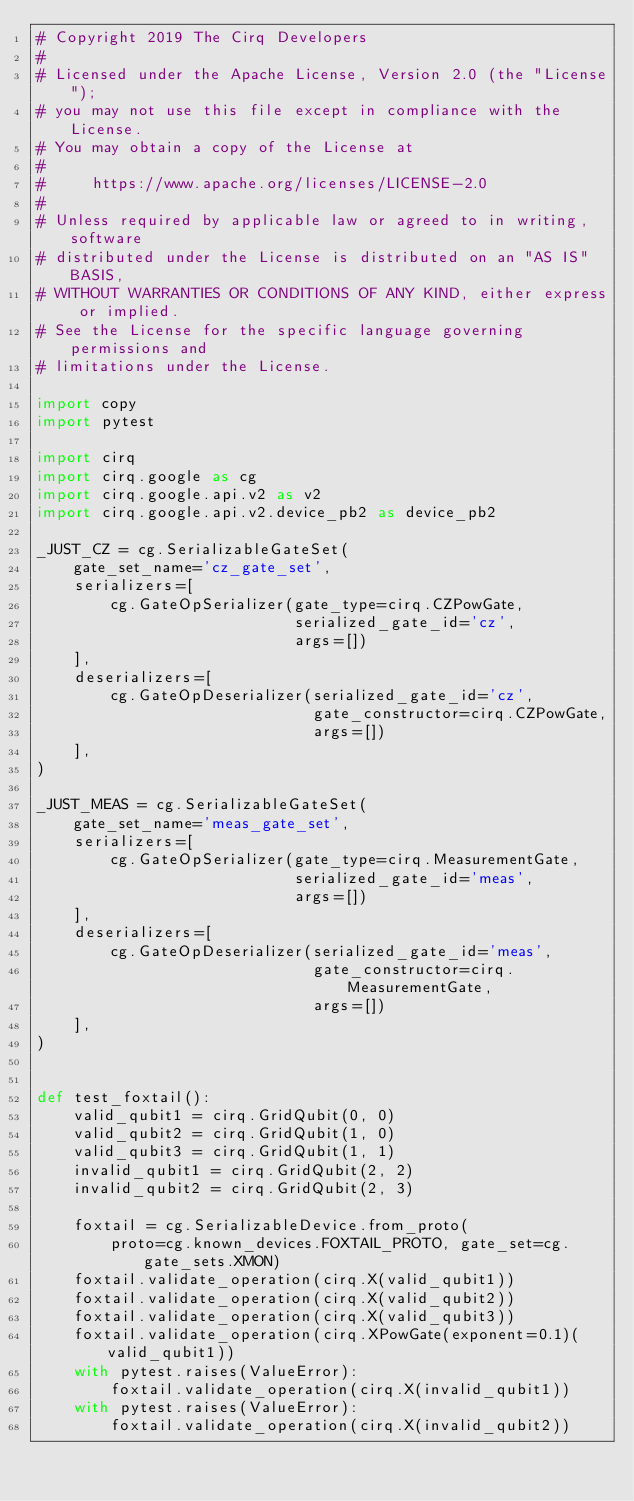Convert code to text. <code><loc_0><loc_0><loc_500><loc_500><_Python_># Copyright 2019 The Cirq Developers
#
# Licensed under the Apache License, Version 2.0 (the "License");
# you may not use this file except in compliance with the License.
# You may obtain a copy of the License at
#
#     https://www.apache.org/licenses/LICENSE-2.0
#
# Unless required by applicable law or agreed to in writing, software
# distributed under the License is distributed on an "AS IS" BASIS,
# WITHOUT WARRANTIES OR CONDITIONS OF ANY KIND, either express or implied.
# See the License for the specific language governing permissions and
# limitations under the License.

import copy
import pytest

import cirq
import cirq.google as cg
import cirq.google.api.v2 as v2
import cirq.google.api.v2.device_pb2 as device_pb2

_JUST_CZ = cg.SerializableGateSet(
    gate_set_name='cz_gate_set',
    serializers=[
        cg.GateOpSerializer(gate_type=cirq.CZPowGate,
                            serialized_gate_id='cz',
                            args=[])
    ],
    deserializers=[
        cg.GateOpDeserializer(serialized_gate_id='cz',
                              gate_constructor=cirq.CZPowGate,
                              args=[])
    ],
)

_JUST_MEAS = cg.SerializableGateSet(
    gate_set_name='meas_gate_set',
    serializers=[
        cg.GateOpSerializer(gate_type=cirq.MeasurementGate,
                            serialized_gate_id='meas',
                            args=[])
    ],
    deserializers=[
        cg.GateOpDeserializer(serialized_gate_id='meas',
                              gate_constructor=cirq.MeasurementGate,
                              args=[])
    ],
)


def test_foxtail():
    valid_qubit1 = cirq.GridQubit(0, 0)
    valid_qubit2 = cirq.GridQubit(1, 0)
    valid_qubit3 = cirq.GridQubit(1, 1)
    invalid_qubit1 = cirq.GridQubit(2, 2)
    invalid_qubit2 = cirq.GridQubit(2, 3)

    foxtail = cg.SerializableDevice.from_proto(
        proto=cg.known_devices.FOXTAIL_PROTO, gate_set=cg.gate_sets.XMON)
    foxtail.validate_operation(cirq.X(valid_qubit1))
    foxtail.validate_operation(cirq.X(valid_qubit2))
    foxtail.validate_operation(cirq.X(valid_qubit3))
    foxtail.validate_operation(cirq.XPowGate(exponent=0.1)(valid_qubit1))
    with pytest.raises(ValueError):
        foxtail.validate_operation(cirq.X(invalid_qubit1))
    with pytest.raises(ValueError):
        foxtail.validate_operation(cirq.X(invalid_qubit2))</code> 